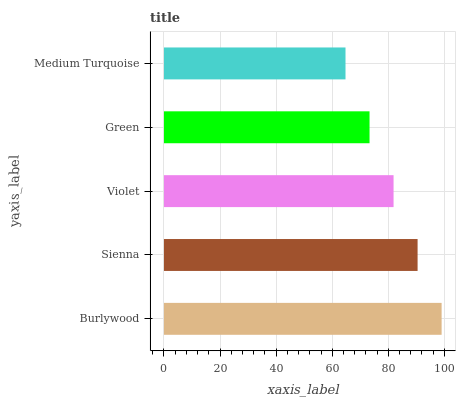Is Medium Turquoise the minimum?
Answer yes or no. Yes. Is Burlywood the maximum?
Answer yes or no. Yes. Is Sienna the minimum?
Answer yes or no. No. Is Sienna the maximum?
Answer yes or no. No. Is Burlywood greater than Sienna?
Answer yes or no. Yes. Is Sienna less than Burlywood?
Answer yes or no. Yes. Is Sienna greater than Burlywood?
Answer yes or no. No. Is Burlywood less than Sienna?
Answer yes or no. No. Is Violet the high median?
Answer yes or no. Yes. Is Violet the low median?
Answer yes or no. Yes. Is Sienna the high median?
Answer yes or no. No. Is Burlywood the low median?
Answer yes or no. No. 